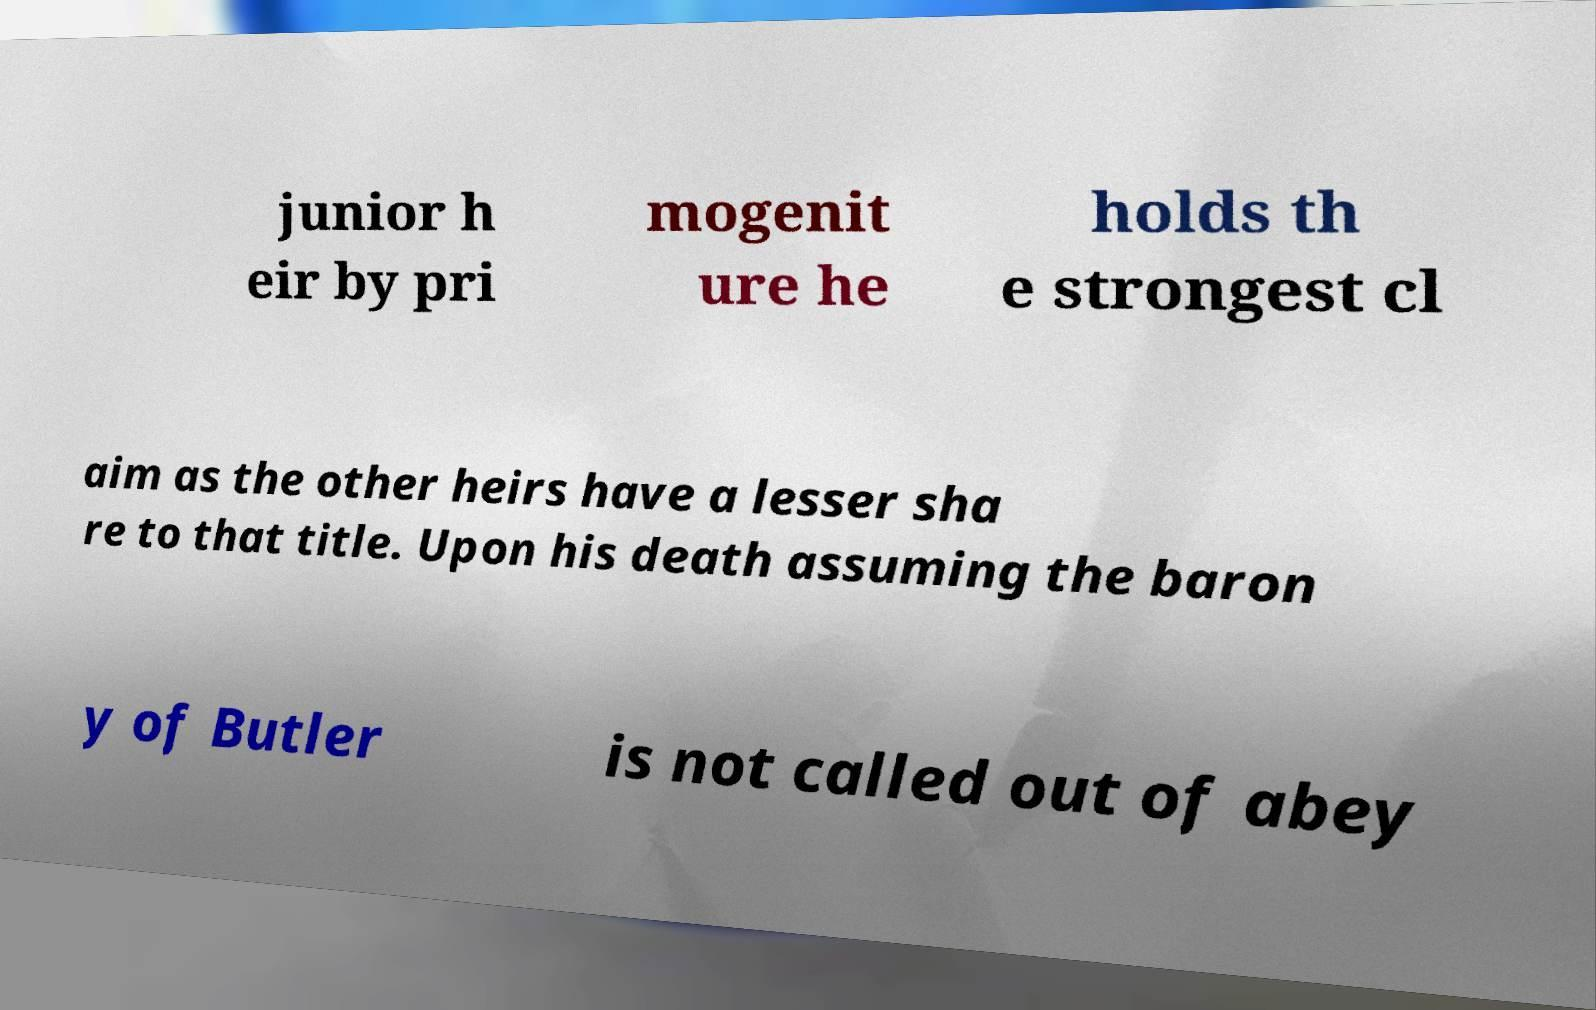Can you accurately transcribe the text from the provided image for me? junior h eir by pri mogenit ure he holds th e strongest cl aim as the other heirs have a lesser sha re to that title. Upon his death assuming the baron y of Butler is not called out of abey 